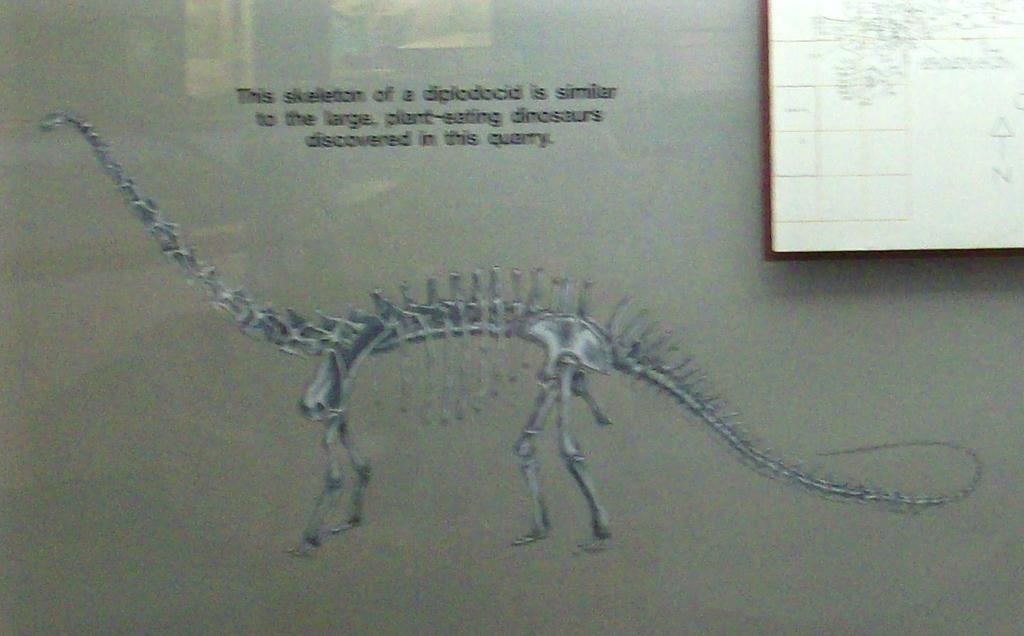<image>
Relay a brief, clear account of the picture shown. A drawing of the skeleton of a diplodocid, a plant-eating dinosaur. 